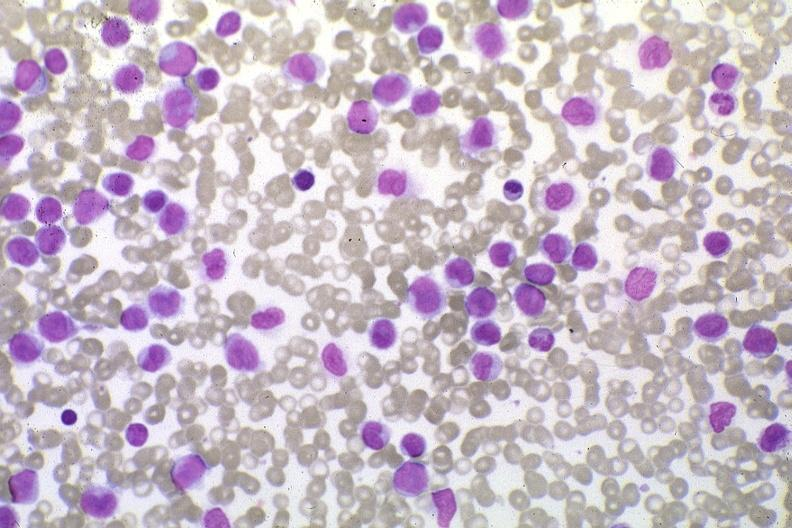does this image show wrights stain pleomorphic leukemic cells in peripheral blood prior to therapy?
Answer the question using a single word or phrase. Yes 